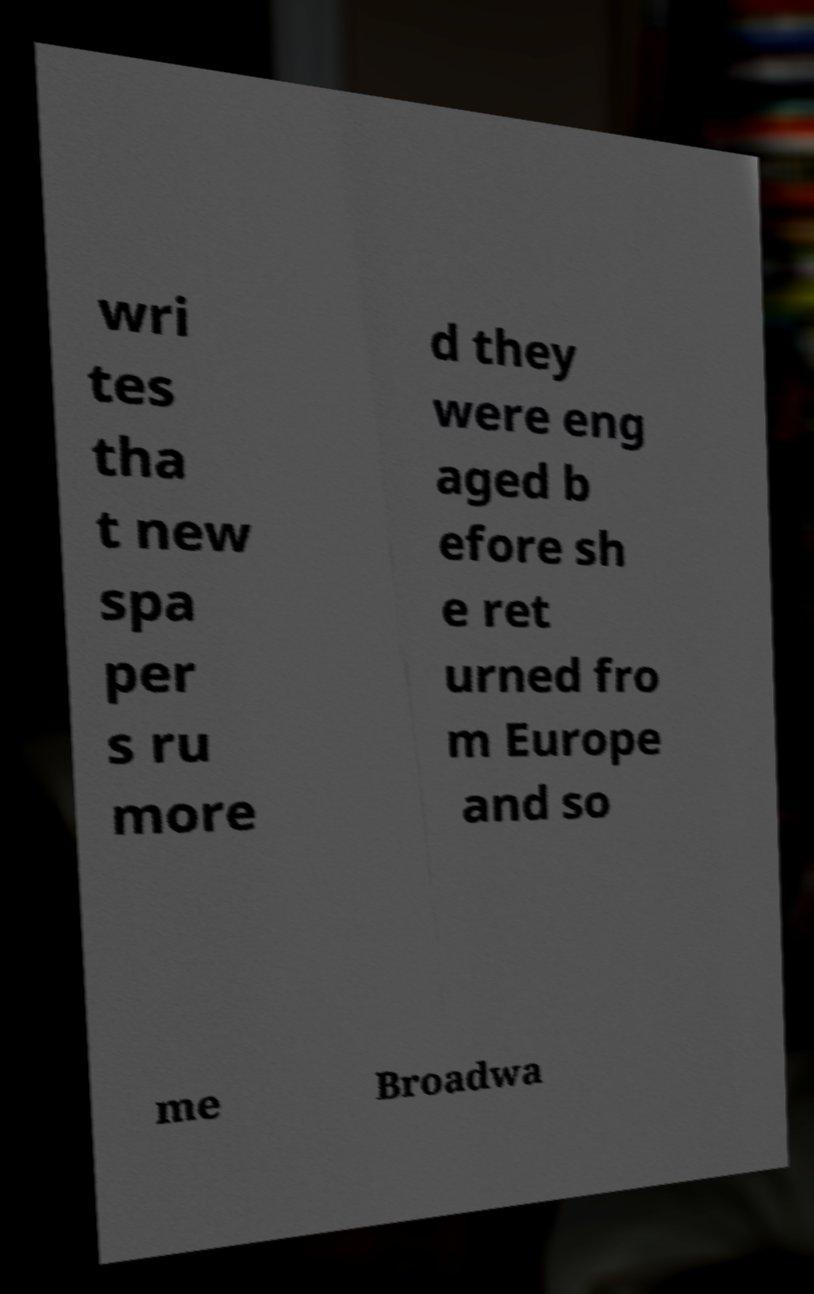There's text embedded in this image that I need extracted. Can you transcribe it verbatim? wri tes tha t new spa per s ru more d they were eng aged b efore sh e ret urned fro m Europe and so me Broadwa 